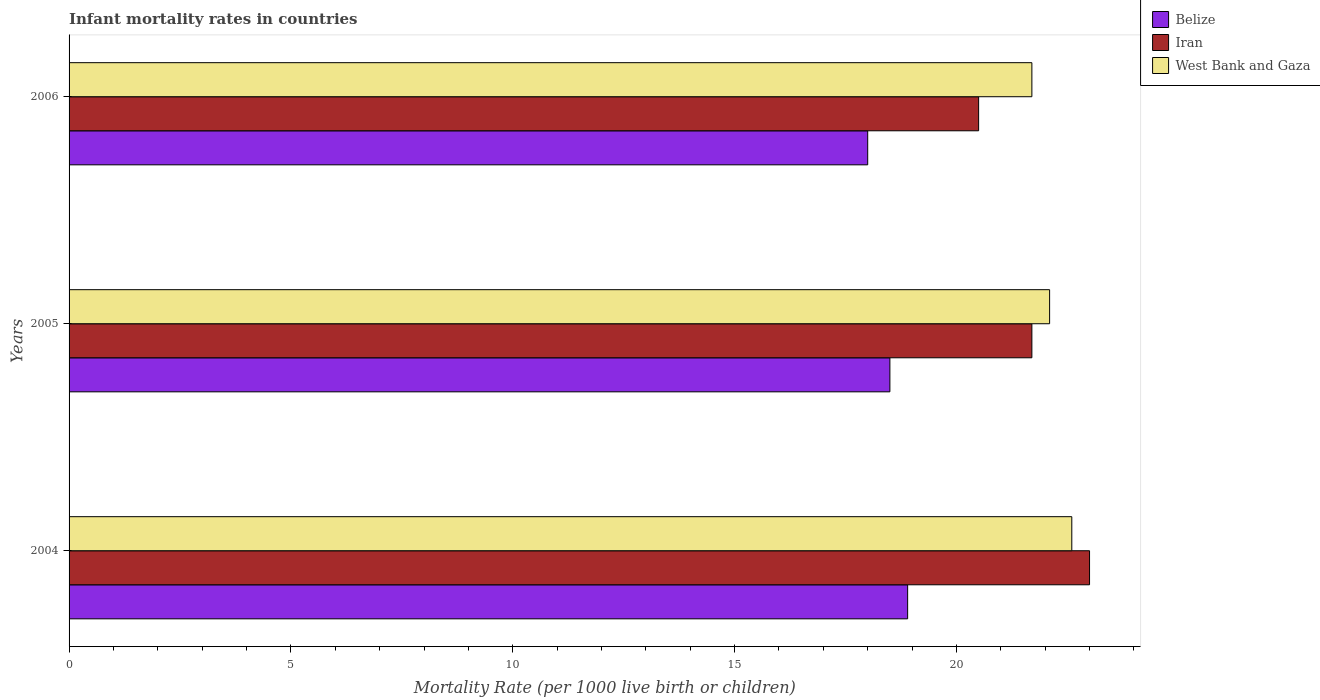How many different coloured bars are there?
Keep it short and to the point. 3. How many groups of bars are there?
Your answer should be compact. 3. Are the number of bars on each tick of the Y-axis equal?
Offer a very short reply. Yes. How many bars are there on the 1st tick from the top?
Your response must be concise. 3. In how many cases, is the number of bars for a given year not equal to the number of legend labels?
Your answer should be very brief. 0. What is the infant mortality rate in West Bank and Gaza in 2004?
Your answer should be very brief. 22.6. Across all years, what is the maximum infant mortality rate in Iran?
Offer a very short reply. 23. Across all years, what is the minimum infant mortality rate in Belize?
Your response must be concise. 18. In which year was the infant mortality rate in West Bank and Gaza maximum?
Make the answer very short. 2004. In which year was the infant mortality rate in Iran minimum?
Make the answer very short. 2006. What is the total infant mortality rate in Iran in the graph?
Make the answer very short. 65.2. What is the difference between the infant mortality rate in Belize in 2004 and that in 2006?
Provide a short and direct response. 0.9. What is the difference between the infant mortality rate in West Bank and Gaza in 2006 and the infant mortality rate in Belize in 2005?
Your answer should be very brief. 3.2. What is the average infant mortality rate in West Bank and Gaza per year?
Give a very brief answer. 22.13. In the year 2005, what is the difference between the infant mortality rate in Belize and infant mortality rate in West Bank and Gaza?
Provide a succinct answer. -3.6. What is the ratio of the infant mortality rate in West Bank and Gaza in 2005 to that in 2006?
Offer a very short reply. 1.02. Is the difference between the infant mortality rate in Belize in 2004 and 2006 greater than the difference between the infant mortality rate in West Bank and Gaza in 2004 and 2006?
Offer a very short reply. No. What is the difference between the highest and the second highest infant mortality rate in Belize?
Provide a succinct answer. 0.4. What is the difference between the highest and the lowest infant mortality rate in Belize?
Offer a very short reply. 0.9. In how many years, is the infant mortality rate in Belize greater than the average infant mortality rate in Belize taken over all years?
Offer a very short reply. 2. Is the sum of the infant mortality rate in Belize in 2005 and 2006 greater than the maximum infant mortality rate in Iran across all years?
Keep it short and to the point. Yes. What does the 2nd bar from the top in 2006 represents?
Offer a terse response. Iran. What does the 2nd bar from the bottom in 2005 represents?
Ensure brevity in your answer.  Iran. How many years are there in the graph?
Make the answer very short. 3. What is the difference between two consecutive major ticks on the X-axis?
Your answer should be compact. 5. Are the values on the major ticks of X-axis written in scientific E-notation?
Your response must be concise. No. Does the graph contain any zero values?
Give a very brief answer. No. Where does the legend appear in the graph?
Ensure brevity in your answer.  Top right. How many legend labels are there?
Provide a short and direct response. 3. How are the legend labels stacked?
Offer a terse response. Vertical. What is the title of the graph?
Give a very brief answer. Infant mortality rates in countries. Does "East Asia (all income levels)" appear as one of the legend labels in the graph?
Give a very brief answer. No. What is the label or title of the X-axis?
Ensure brevity in your answer.  Mortality Rate (per 1000 live birth or children). What is the Mortality Rate (per 1000 live birth or children) in Iran in 2004?
Offer a terse response. 23. What is the Mortality Rate (per 1000 live birth or children) in West Bank and Gaza in 2004?
Offer a terse response. 22.6. What is the Mortality Rate (per 1000 live birth or children) of Iran in 2005?
Provide a short and direct response. 21.7. What is the Mortality Rate (per 1000 live birth or children) in West Bank and Gaza in 2005?
Provide a succinct answer. 22.1. What is the Mortality Rate (per 1000 live birth or children) of Belize in 2006?
Offer a very short reply. 18. What is the Mortality Rate (per 1000 live birth or children) in West Bank and Gaza in 2006?
Your answer should be compact. 21.7. Across all years, what is the maximum Mortality Rate (per 1000 live birth or children) of Iran?
Your answer should be very brief. 23. Across all years, what is the maximum Mortality Rate (per 1000 live birth or children) in West Bank and Gaza?
Ensure brevity in your answer.  22.6. Across all years, what is the minimum Mortality Rate (per 1000 live birth or children) of West Bank and Gaza?
Your answer should be compact. 21.7. What is the total Mortality Rate (per 1000 live birth or children) in Belize in the graph?
Offer a very short reply. 55.4. What is the total Mortality Rate (per 1000 live birth or children) of Iran in the graph?
Offer a terse response. 65.2. What is the total Mortality Rate (per 1000 live birth or children) of West Bank and Gaza in the graph?
Make the answer very short. 66.4. What is the difference between the Mortality Rate (per 1000 live birth or children) in Belize in 2004 and that in 2005?
Offer a terse response. 0.4. What is the difference between the Mortality Rate (per 1000 live birth or children) of West Bank and Gaza in 2004 and that in 2005?
Offer a terse response. 0.5. What is the difference between the Mortality Rate (per 1000 live birth or children) of Iran in 2005 and that in 2006?
Offer a very short reply. 1.2. What is the difference between the Mortality Rate (per 1000 live birth or children) in West Bank and Gaza in 2005 and that in 2006?
Your response must be concise. 0.4. What is the difference between the Mortality Rate (per 1000 live birth or children) of Belize in 2004 and the Mortality Rate (per 1000 live birth or children) of Iran in 2005?
Keep it short and to the point. -2.8. What is the difference between the Mortality Rate (per 1000 live birth or children) of Iran in 2004 and the Mortality Rate (per 1000 live birth or children) of West Bank and Gaza in 2005?
Your answer should be very brief. 0.9. What is the difference between the Mortality Rate (per 1000 live birth or children) of Belize in 2004 and the Mortality Rate (per 1000 live birth or children) of Iran in 2006?
Your answer should be compact. -1.6. What is the difference between the Mortality Rate (per 1000 live birth or children) in Belize in 2005 and the Mortality Rate (per 1000 live birth or children) in Iran in 2006?
Ensure brevity in your answer.  -2. What is the difference between the Mortality Rate (per 1000 live birth or children) of Belize in 2005 and the Mortality Rate (per 1000 live birth or children) of West Bank and Gaza in 2006?
Offer a very short reply. -3.2. What is the difference between the Mortality Rate (per 1000 live birth or children) of Iran in 2005 and the Mortality Rate (per 1000 live birth or children) of West Bank and Gaza in 2006?
Keep it short and to the point. 0. What is the average Mortality Rate (per 1000 live birth or children) in Belize per year?
Offer a terse response. 18.47. What is the average Mortality Rate (per 1000 live birth or children) in Iran per year?
Keep it short and to the point. 21.73. What is the average Mortality Rate (per 1000 live birth or children) in West Bank and Gaza per year?
Provide a short and direct response. 22.13. In the year 2004, what is the difference between the Mortality Rate (per 1000 live birth or children) in Belize and Mortality Rate (per 1000 live birth or children) in Iran?
Ensure brevity in your answer.  -4.1. In the year 2004, what is the difference between the Mortality Rate (per 1000 live birth or children) in Belize and Mortality Rate (per 1000 live birth or children) in West Bank and Gaza?
Provide a succinct answer. -3.7. In the year 2004, what is the difference between the Mortality Rate (per 1000 live birth or children) of Iran and Mortality Rate (per 1000 live birth or children) of West Bank and Gaza?
Keep it short and to the point. 0.4. In the year 2005, what is the difference between the Mortality Rate (per 1000 live birth or children) in Belize and Mortality Rate (per 1000 live birth or children) in Iran?
Ensure brevity in your answer.  -3.2. What is the ratio of the Mortality Rate (per 1000 live birth or children) in Belize in 2004 to that in 2005?
Make the answer very short. 1.02. What is the ratio of the Mortality Rate (per 1000 live birth or children) of Iran in 2004 to that in 2005?
Keep it short and to the point. 1.06. What is the ratio of the Mortality Rate (per 1000 live birth or children) of West Bank and Gaza in 2004 to that in 2005?
Your answer should be very brief. 1.02. What is the ratio of the Mortality Rate (per 1000 live birth or children) of Belize in 2004 to that in 2006?
Provide a short and direct response. 1.05. What is the ratio of the Mortality Rate (per 1000 live birth or children) in Iran in 2004 to that in 2006?
Offer a terse response. 1.12. What is the ratio of the Mortality Rate (per 1000 live birth or children) of West Bank and Gaza in 2004 to that in 2006?
Keep it short and to the point. 1.04. What is the ratio of the Mortality Rate (per 1000 live birth or children) of Belize in 2005 to that in 2006?
Your answer should be very brief. 1.03. What is the ratio of the Mortality Rate (per 1000 live birth or children) in Iran in 2005 to that in 2006?
Your response must be concise. 1.06. What is the ratio of the Mortality Rate (per 1000 live birth or children) in West Bank and Gaza in 2005 to that in 2006?
Offer a terse response. 1.02. What is the difference between the highest and the second highest Mortality Rate (per 1000 live birth or children) in Belize?
Provide a short and direct response. 0.4. What is the difference between the highest and the second highest Mortality Rate (per 1000 live birth or children) of West Bank and Gaza?
Provide a short and direct response. 0.5. What is the difference between the highest and the lowest Mortality Rate (per 1000 live birth or children) of Belize?
Give a very brief answer. 0.9. 